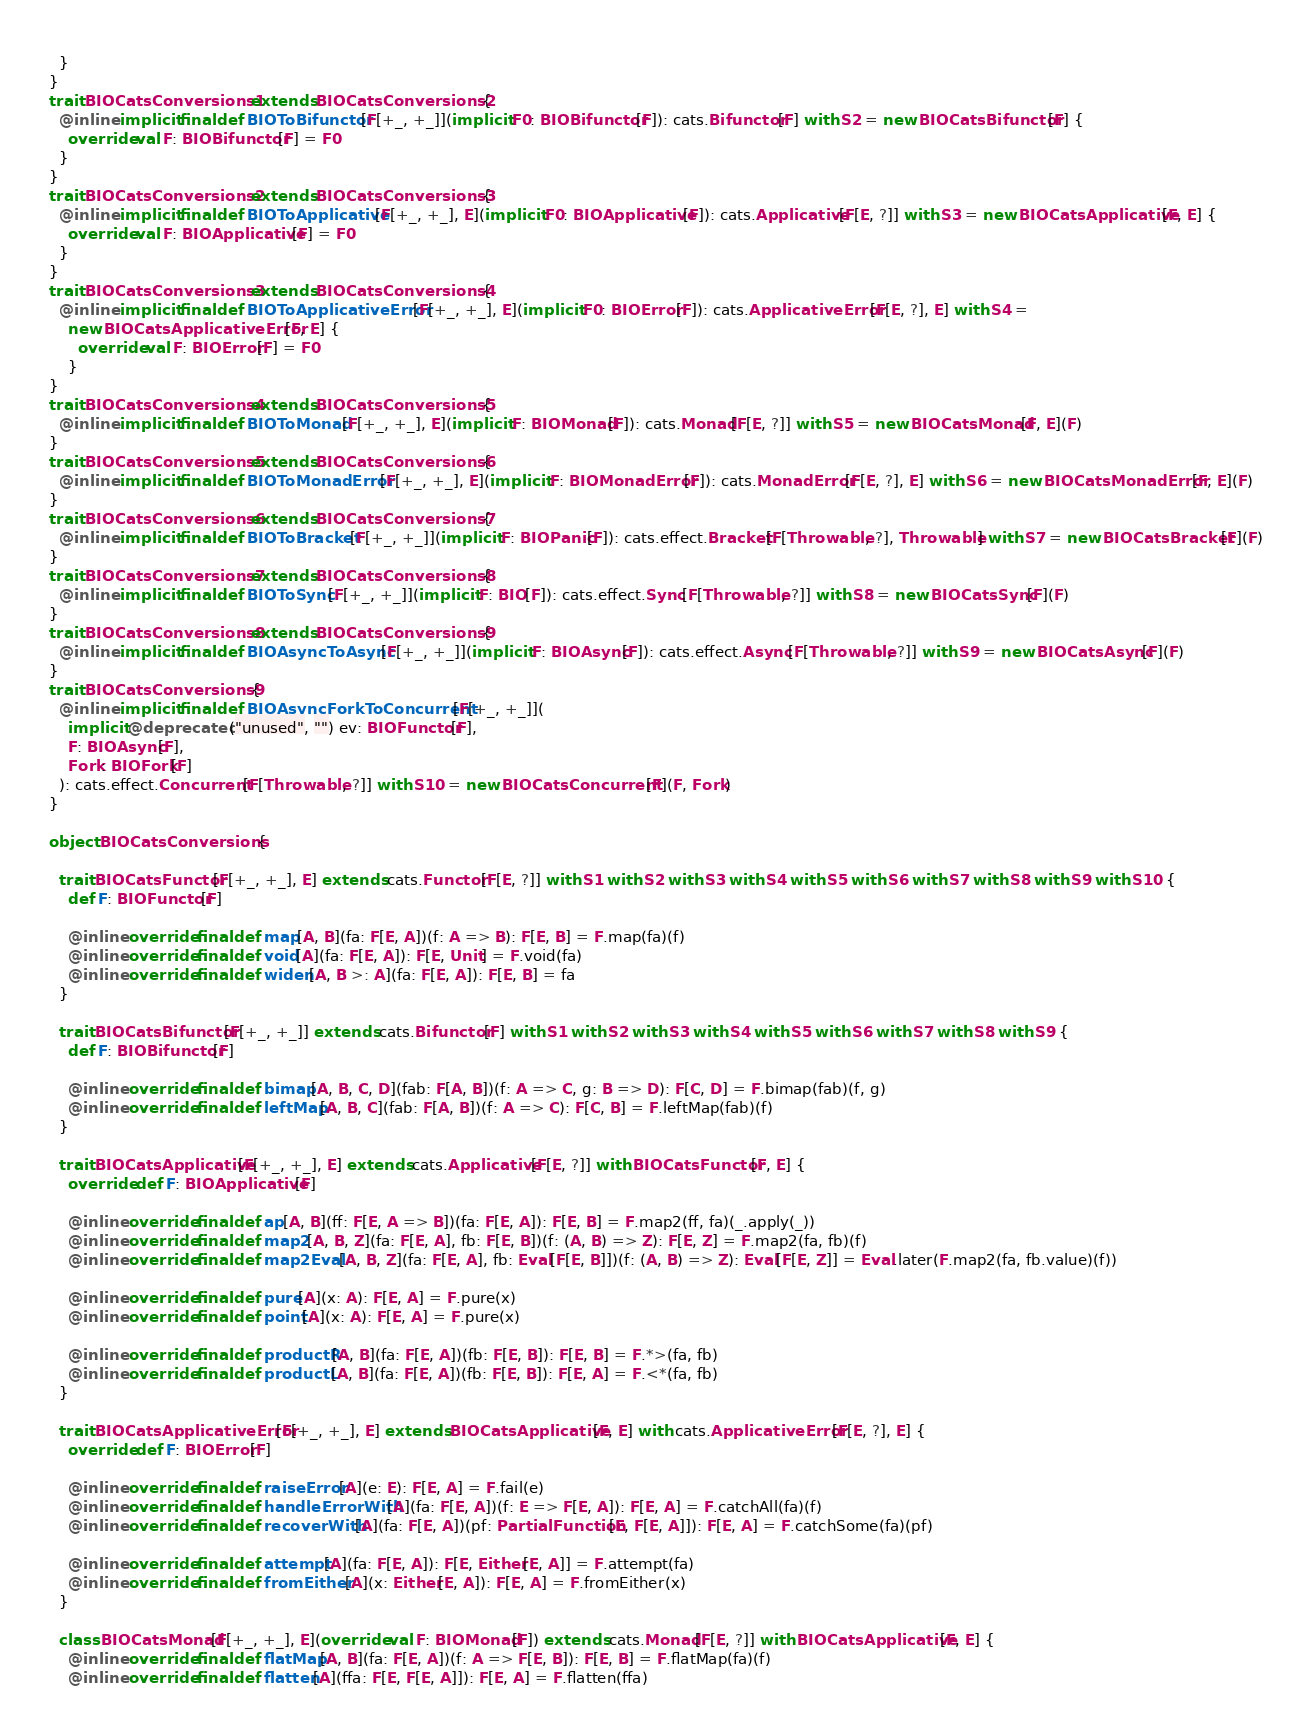<code> <loc_0><loc_0><loc_500><loc_500><_Scala_>  }
}
trait BIOCatsConversions1 extends BIOCatsConversions2 {
  @inline implicit final def BIOToBifunctor[F[+_, +_]](implicit F0: BIOBifunctor[F]): cats.Bifunctor[F] with S2 = new BIOCatsBifunctor[F] {
    override val F: BIOBifunctor[F] = F0
  }
}
trait BIOCatsConversions2 extends BIOCatsConversions3 {
  @inline implicit final def BIOToApplicative[F[+_, +_], E](implicit F0: BIOApplicative[F]): cats.Applicative[F[E, ?]] with S3 = new BIOCatsApplicative[F, E] {
    override val F: BIOApplicative[F] = F0
  }
}
trait BIOCatsConversions3 extends BIOCatsConversions4 {
  @inline implicit final def BIOToApplicativeError[F[+_, +_], E](implicit F0: BIOError[F]): cats.ApplicativeError[F[E, ?], E] with S4 =
    new BIOCatsApplicativeError[F, E] {
      override val F: BIOError[F] = F0
    }
}
trait BIOCatsConversions4 extends BIOCatsConversions5 {
  @inline implicit final def BIOToMonad[F[+_, +_], E](implicit F: BIOMonad[F]): cats.Monad[F[E, ?]] with S5 = new BIOCatsMonad[F, E](F)
}
trait BIOCatsConversions5 extends BIOCatsConversions6 {
  @inline implicit final def BIOToMonadError[F[+_, +_], E](implicit F: BIOMonadError[F]): cats.MonadError[F[E, ?], E] with S6 = new BIOCatsMonadError[F, E](F)
}
trait BIOCatsConversions6 extends BIOCatsConversions7 {
  @inline implicit final def BIOToBracket[F[+_, +_]](implicit F: BIOPanic[F]): cats.effect.Bracket[F[Throwable, ?], Throwable] with S7 = new BIOCatsBracket[F](F)
}
trait BIOCatsConversions7 extends BIOCatsConversions8 {
  @inline implicit final def BIOToSync[F[+_, +_]](implicit F: BIO[F]): cats.effect.Sync[F[Throwable, ?]] with S8 = new BIOCatsSync[F](F)
}
trait BIOCatsConversions8 extends BIOCatsConversions9 {
  @inline implicit final def BIOAsyncToAsync[F[+_, +_]](implicit F: BIOAsync[F]): cats.effect.Async[F[Throwable, ?]] with S9 = new BIOCatsAsync[F](F)
}
trait BIOCatsConversions9 {
  @inline implicit final def BIOAsyncForkToConcurrent[F[+_, +_]](
    implicit @deprecated("unused", "") ev: BIOFunctor[F],
    F: BIOAsync[F],
    Fork: BIOFork[F]
  ): cats.effect.Concurrent[F[Throwable, ?]] with S10 = new BIOCatsConcurrent[F](F, Fork)
}

object BIOCatsConversions {

  trait BIOCatsFunctor[F[+_, +_], E] extends cats.Functor[F[E, ?]] with S1 with S2 with S3 with S4 with S5 with S6 with S7 with S8 with S9 with S10 {
    def F: BIOFunctor[F]

    @inline override final def map[A, B](fa: F[E, A])(f: A => B): F[E, B] = F.map(fa)(f)
    @inline override final def void[A](fa: F[E, A]): F[E, Unit] = F.void(fa)
    @inline override final def widen[A, B >: A](fa: F[E, A]): F[E, B] = fa
  }

  trait BIOCatsBifunctor[F[+_, +_]] extends cats.Bifunctor[F] with S1 with S2 with S3 with S4 with S5 with S6 with S7 with S8 with S9 {
    def F: BIOBifunctor[F]

    @inline override final def bimap[A, B, C, D](fab: F[A, B])(f: A => C, g: B => D): F[C, D] = F.bimap(fab)(f, g)
    @inline override final def leftMap[A, B, C](fab: F[A, B])(f: A => C): F[C, B] = F.leftMap(fab)(f)
  }

  trait BIOCatsApplicative[F[+_, +_], E] extends cats.Applicative[F[E, ?]] with BIOCatsFunctor[F, E] {
    override def F: BIOApplicative[F]

    @inline override final def ap[A, B](ff: F[E, A => B])(fa: F[E, A]): F[E, B] = F.map2(ff, fa)(_.apply(_))
    @inline override final def map2[A, B, Z](fa: F[E, A], fb: F[E, B])(f: (A, B) => Z): F[E, Z] = F.map2(fa, fb)(f)
    @inline override final def map2Eval[A, B, Z](fa: F[E, A], fb: Eval[F[E, B]])(f: (A, B) => Z): Eval[F[E, Z]] = Eval.later(F.map2(fa, fb.value)(f))

    @inline override final def pure[A](x: A): F[E, A] = F.pure(x)
    @inline override final def point[A](x: A): F[E, A] = F.pure(x)

    @inline override final def productR[A, B](fa: F[E, A])(fb: F[E, B]): F[E, B] = F.*>(fa, fb)
    @inline override final def productL[A, B](fa: F[E, A])(fb: F[E, B]): F[E, A] = F.<*(fa, fb)
  }

  trait BIOCatsApplicativeError[F[+_, +_], E] extends BIOCatsApplicative[F, E] with cats.ApplicativeError[F[E, ?], E] {
    override def F: BIOError[F]

    @inline override final def raiseError[A](e: E): F[E, A] = F.fail(e)
    @inline override final def handleErrorWith[A](fa: F[E, A])(f: E => F[E, A]): F[E, A] = F.catchAll(fa)(f)
    @inline override final def recoverWith[A](fa: F[E, A])(pf: PartialFunction[E, F[E, A]]): F[E, A] = F.catchSome(fa)(pf)

    @inline override final def attempt[A](fa: F[E, A]): F[E, Either[E, A]] = F.attempt(fa)
    @inline override final def fromEither[A](x: Either[E, A]): F[E, A] = F.fromEither(x)
  }

  class BIOCatsMonad[F[+_, +_], E](override val F: BIOMonad[F]) extends cats.Monad[F[E, ?]] with BIOCatsApplicative[F, E] {
    @inline override final def flatMap[A, B](fa: F[E, A])(f: A => F[E, B]): F[E, B] = F.flatMap(fa)(f)
    @inline override final def flatten[A](ffa: F[E, F[E, A]]): F[E, A] = F.flatten(ffa)</code> 